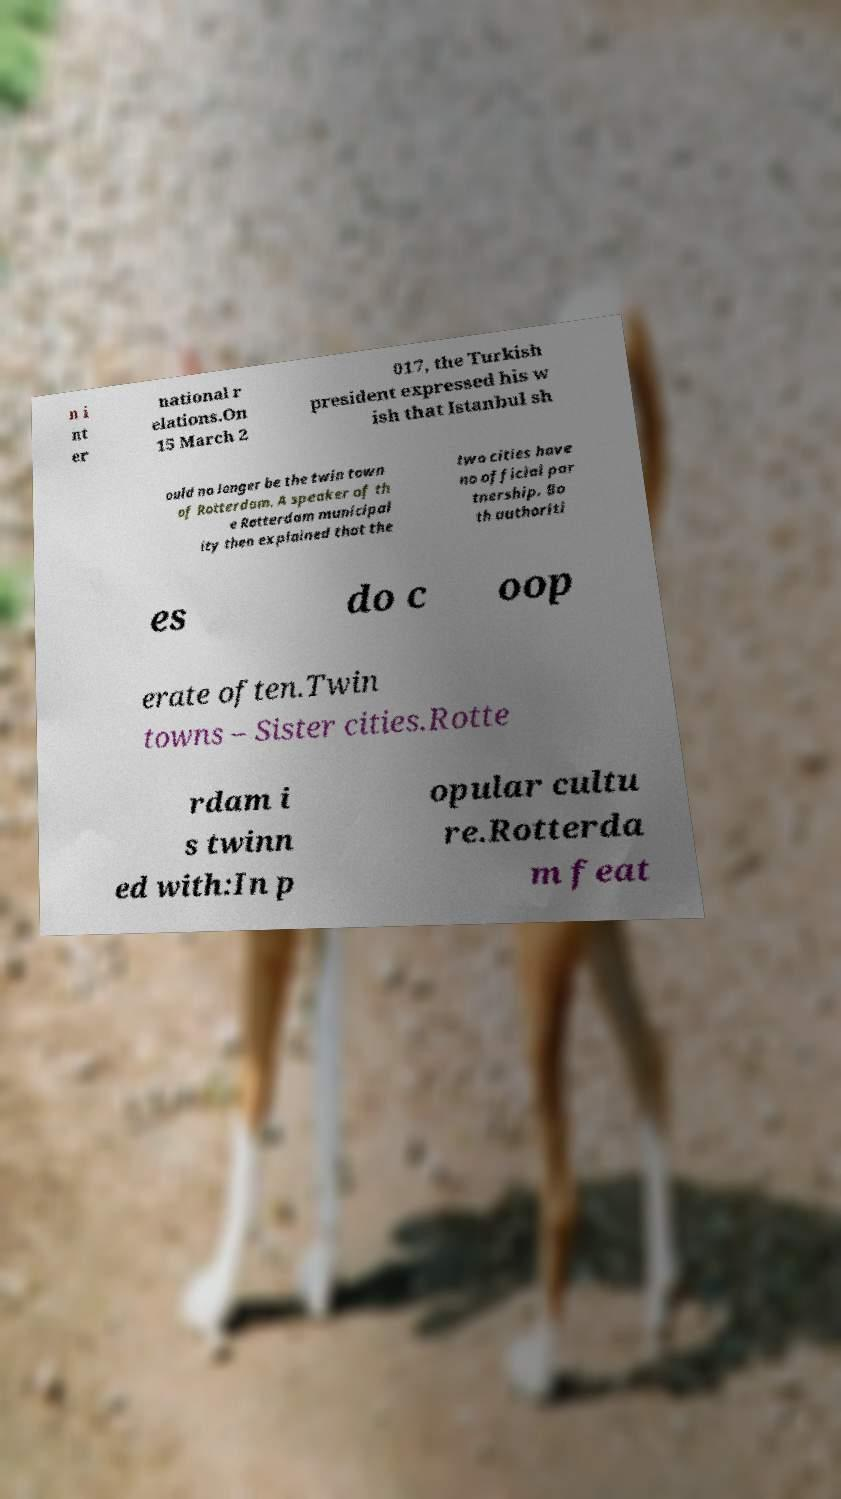Could you assist in decoding the text presented in this image and type it out clearly? n i nt er national r elations.On 15 March 2 017, the Turkish president expressed his w ish that Istanbul sh ould no longer be the twin town of Rotterdam. A speaker of th e Rotterdam municipal ity then explained that the two cities have no official par tnership. Bo th authoriti es do c oop erate often.Twin towns – Sister cities.Rotte rdam i s twinn ed with:In p opular cultu re.Rotterda m feat 